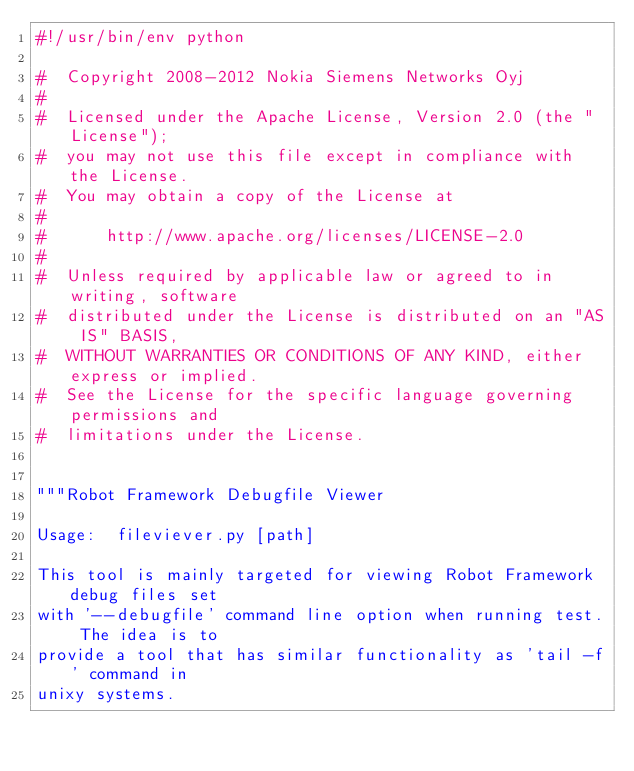<code> <loc_0><loc_0><loc_500><loc_500><_Python_>#!/usr/bin/env python

#  Copyright 2008-2012 Nokia Siemens Networks Oyj
#
#  Licensed under the Apache License, Version 2.0 (the "License");
#  you may not use this file except in compliance with the License.
#  You may obtain a copy of the License at
#
#      http://www.apache.org/licenses/LICENSE-2.0
#
#  Unless required by applicable law or agreed to in writing, software
#  distributed under the License is distributed on an "AS IS" BASIS,
#  WITHOUT WARRANTIES OR CONDITIONS OF ANY KIND, either express or implied.
#  See the License for the specific language governing permissions and
#  limitations under the License.


"""Robot Framework Debugfile Viewer

Usage:  fileviever.py [path]

This tool is mainly targeted for viewing Robot Framework debug files set
with '--debugfile' command line option when running test. The idea is to
provide a tool that has similar functionality as 'tail -f' command in 
unixy systems.
</code> 